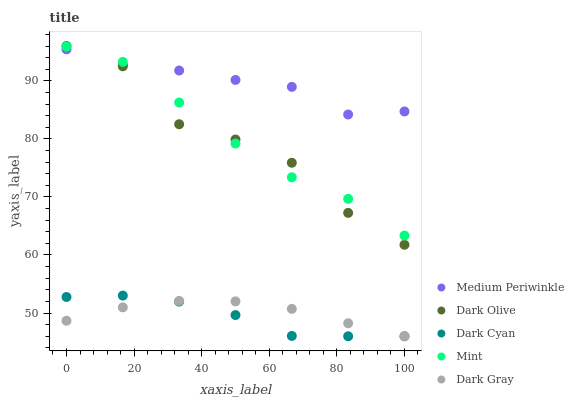Does Dark Cyan have the minimum area under the curve?
Answer yes or no. Yes. Does Medium Periwinkle have the maximum area under the curve?
Answer yes or no. Yes. Does Mint have the minimum area under the curve?
Answer yes or no. No. Does Mint have the maximum area under the curve?
Answer yes or no. No. Is Dark Gray the smoothest?
Answer yes or no. Yes. Is Dark Olive the roughest?
Answer yes or no. Yes. Is Mint the smoothest?
Answer yes or no. No. Is Mint the roughest?
Answer yes or no. No. Does Dark Cyan have the lowest value?
Answer yes or no. Yes. Does Mint have the lowest value?
Answer yes or no. No. Does Dark Olive have the highest value?
Answer yes or no. Yes. Does Mint have the highest value?
Answer yes or no. No. Is Dark Gray less than Dark Olive?
Answer yes or no. Yes. Is Medium Periwinkle greater than Dark Cyan?
Answer yes or no. Yes. Does Dark Olive intersect Mint?
Answer yes or no. Yes. Is Dark Olive less than Mint?
Answer yes or no. No. Is Dark Olive greater than Mint?
Answer yes or no. No. Does Dark Gray intersect Dark Olive?
Answer yes or no. No. 